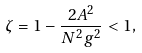<formula> <loc_0><loc_0><loc_500><loc_500>\zeta = 1 - \frac { 2 A ^ { 2 } } { N ^ { 2 } g ^ { 2 } } < 1 ,</formula> 